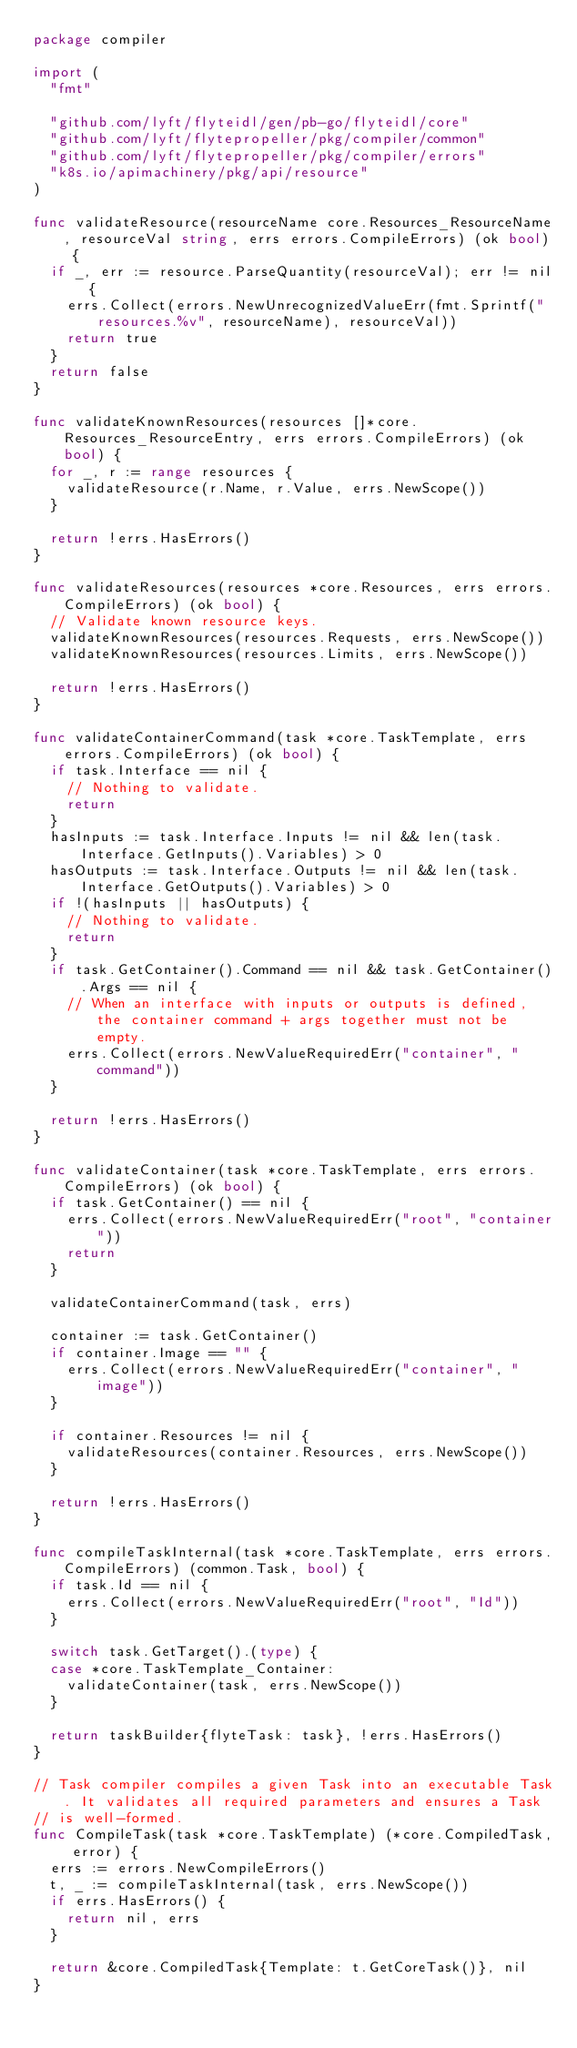<code> <loc_0><loc_0><loc_500><loc_500><_Go_>package compiler

import (
	"fmt"

	"github.com/lyft/flyteidl/gen/pb-go/flyteidl/core"
	"github.com/lyft/flytepropeller/pkg/compiler/common"
	"github.com/lyft/flytepropeller/pkg/compiler/errors"
	"k8s.io/apimachinery/pkg/api/resource"
)

func validateResource(resourceName core.Resources_ResourceName, resourceVal string, errs errors.CompileErrors) (ok bool) {
	if _, err := resource.ParseQuantity(resourceVal); err != nil {
		errs.Collect(errors.NewUnrecognizedValueErr(fmt.Sprintf("resources.%v", resourceName), resourceVal))
		return true
	}
	return false
}

func validateKnownResources(resources []*core.Resources_ResourceEntry, errs errors.CompileErrors) (ok bool) {
	for _, r := range resources {
		validateResource(r.Name, r.Value, errs.NewScope())
	}

	return !errs.HasErrors()
}

func validateResources(resources *core.Resources, errs errors.CompileErrors) (ok bool) {
	// Validate known resource keys.
	validateKnownResources(resources.Requests, errs.NewScope())
	validateKnownResources(resources.Limits, errs.NewScope())

	return !errs.HasErrors()
}

func validateContainerCommand(task *core.TaskTemplate, errs errors.CompileErrors) (ok bool) {
	if task.Interface == nil {
		// Nothing to validate.
		return
	}
	hasInputs := task.Interface.Inputs != nil && len(task.Interface.GetInputs().Variables) > 0
	hasOutputs := task.Interface.Outputs != nil && len(task.Interface.GetOutputs().Variables) > 0
	if !(hasInputs || hasOutputs) {
		// Nothing to validate.
		return
	}
	if task.GetContainer().Command == nil && task.GetContainer().Args == nil {
		// When an interface with inputs or outputs is defined, the container command + args together must not be empty.
		errs.Collect(errors.NewValueRequiredErr("container", "command"))
	}

	return !errs.HasErrors()
}

func validateContainer(task *core.TaskTemplate, errs errors.CompileErrors) (ok bool) {
	if task.GetContainer() == nil {
		errs.Collect(errors.NewValueRequiredErr("root", "container"))
		return
	}

	validateContainerCommand(task, errs)

	container := task.GetContainer()
	if container.Image == "" {
		errs.Collect(errors.NewValueRequiredErr("container", "image"))
	}

	if container.Resources != nil {
		validateResources(container.Resources, errs.NewScope())
	}

	return !errs.HasErrors()
}

func compileTaskInternal(task *core.TaskTemplate, errs errors.CompileErrors) (common.Task, bool) {
	if task.Id == nil {
		errs.Collect(errors.NewValueRequiredErr("root", "Id"))
	}

	switch task.GetTarget().(type) {
	case *core.TaskTemplate_Container:
		validateContainer(task, errs.NewScope())
	}

	return taskBuilder{flyteTask: task}, !errs.HasErrors()
}

// Task compiler compiles a given Task into an executable Task. It validates all required parameters and ensures a Task
// is well-formed.
func CompileTask(task *core.TaskTemplate) (*core.CompiledTask, error) {
	errs := errors.NewCompileErrors()
	t, _ := compileTaskInternal(task, errs.NewScope())
	if errs.HasErrors() {
		return nil, errs
	}

	return &core.CompiledTask{Template: t.GetCoreTask()}, nil
}
</code> 